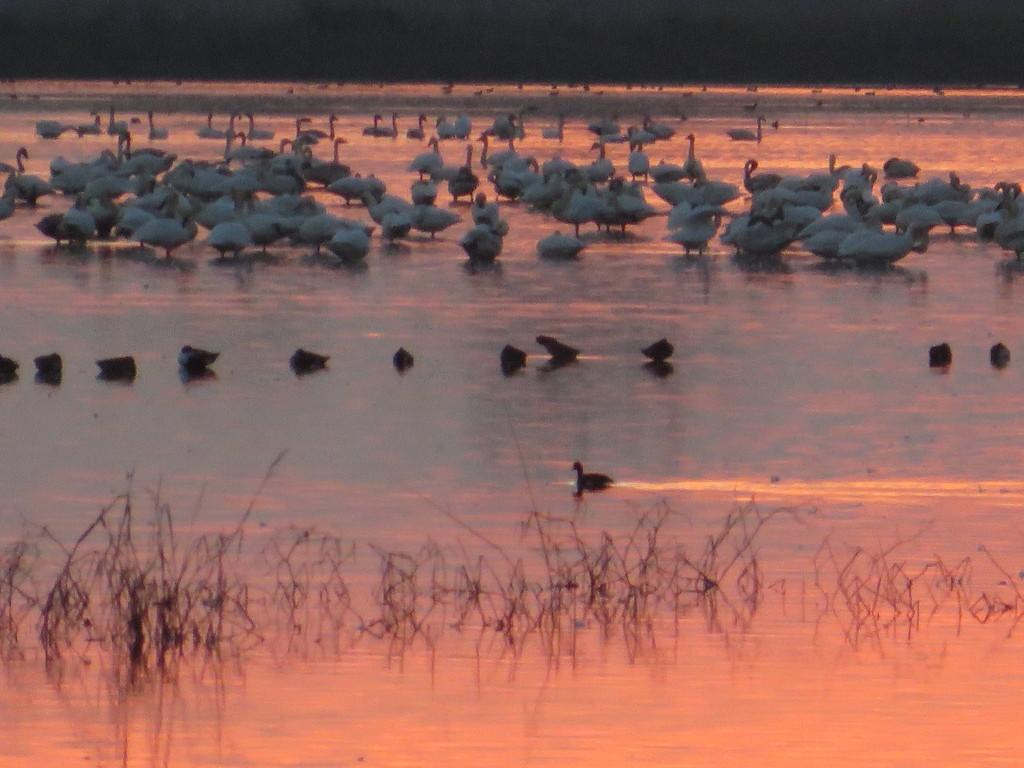What is the primary feature of the ground in the image? The ground in the image is full of water. What type of animals can be seen in the image? There are birds visible in the image. What can be seen at the bottom of the image? There are stems at the bottom of the image. What type of knowledge is being shared by the girl in the image? There is no girl present in the image, so no knowledge can be shared by a girl. 